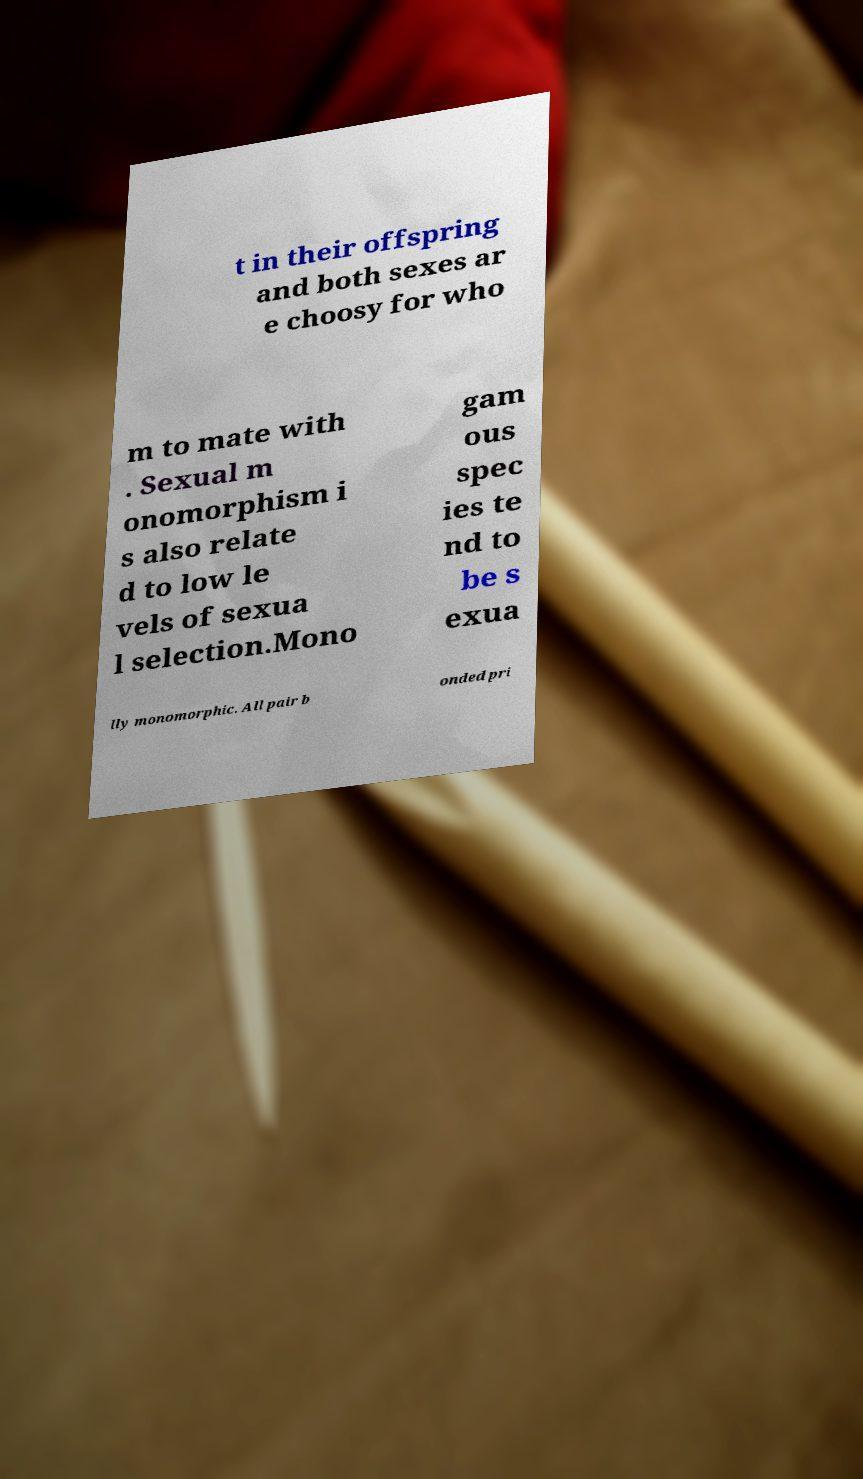There's text embedded in this image that I need extracted. Can you transcribe it verbatim? t in their offspring and both sexes ar e choosy for who m to mate with . Sexual m onomorphism i s also relate d to low le vels of sexua l selection.Mono gam ous spec ies te nd to be s exua lly monomorphic. All pair b onded pri 